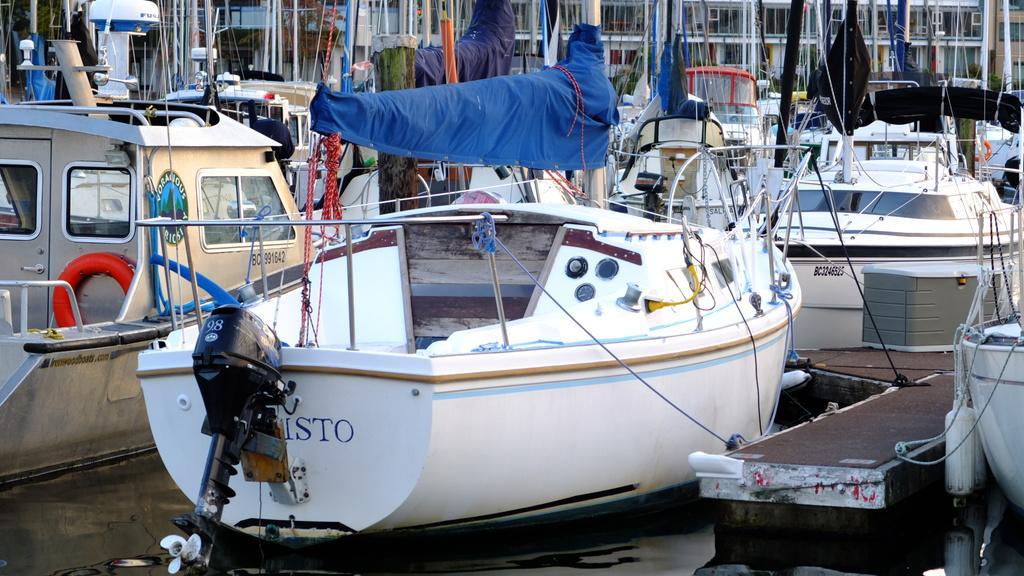In one or two sentences, can you explain what this image depicts? In this picture we can see some boats in water and some buildings in the background. 